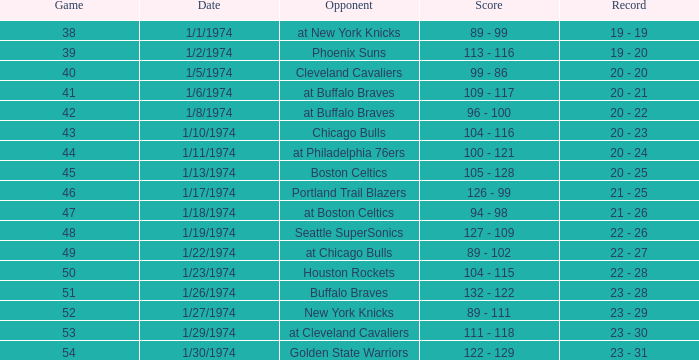After the game on 1/27/1974, what was the record at the end of the 51st match? 23 - 29. 